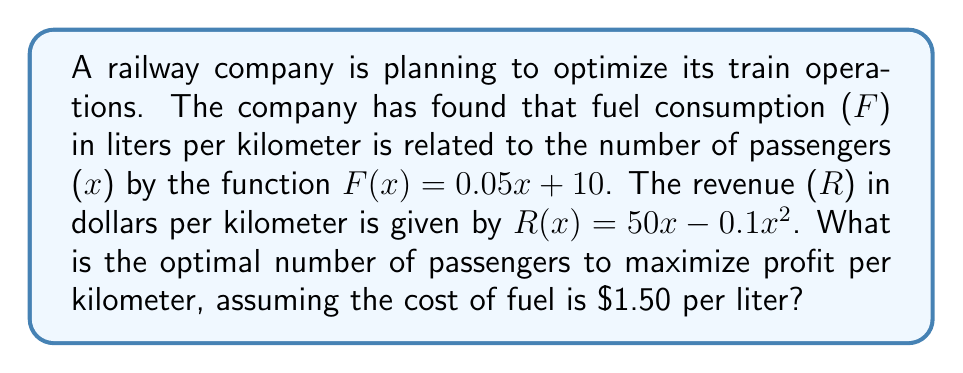Can you solve this math problem? To solve this problem, we need to follow these steps:

1) First, let's define the profit function. Profit (P) is revenue minus cost:
   $P(x) = R(x) - 1.50 \cdot F(x)$

2) Substitute the given functions:
   $P(x) = (50x - 0.1x^2) - 1.50(0.05x + 10)$

3) Simplify:
   $P(x) = 50x - 0.1x^2 - 0.075x - 15$
   $P(x) = 49.925x - 0.1x^2 - 15$

4) To find the maximum profit, we need to find where the derivative of P(x) equals zero:
   $\frac{dP}{dx} = 49.925 - 0.2x$

5) Set this equal to zero and solve for x:
   $49.925 - 0.2x = 0$
   $0.2x = 49.925$
   $x = 249.625$

6) To confirm this is a maximum, we can check the second derivative:
   $\frac{d^2P}{dx^2} = -0.2$, which is negative, confirming a maximum.

7) Since we can't have a fractional number of passengers, we round to the nearest whole number:
   $x = 250$ passengers
Answer: The optimal number of passengers to maximize profit per kilometer is 250. 